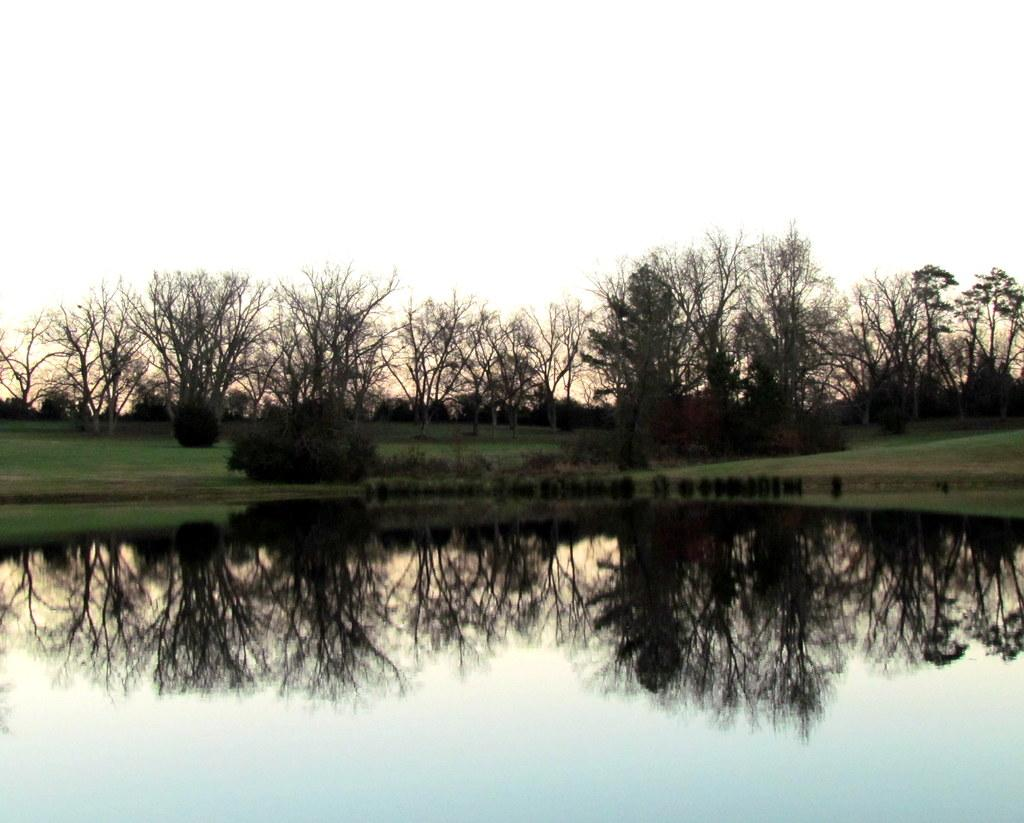What type of view is shown in the image? The image is an outside view. What body of water is present at the bottom of the image? There is a river at the bottom of the image. What type of vegetation can be seen in the background of the image? There are trees and grass in the background of the image. What is visible at the top of the image? The sky is visible at the top of the image. What type of advertisement can be seen on the river in the image? There is no advertisement present on the river in the image. Can you see a train passing by in the image? There is no train visible in the image. 